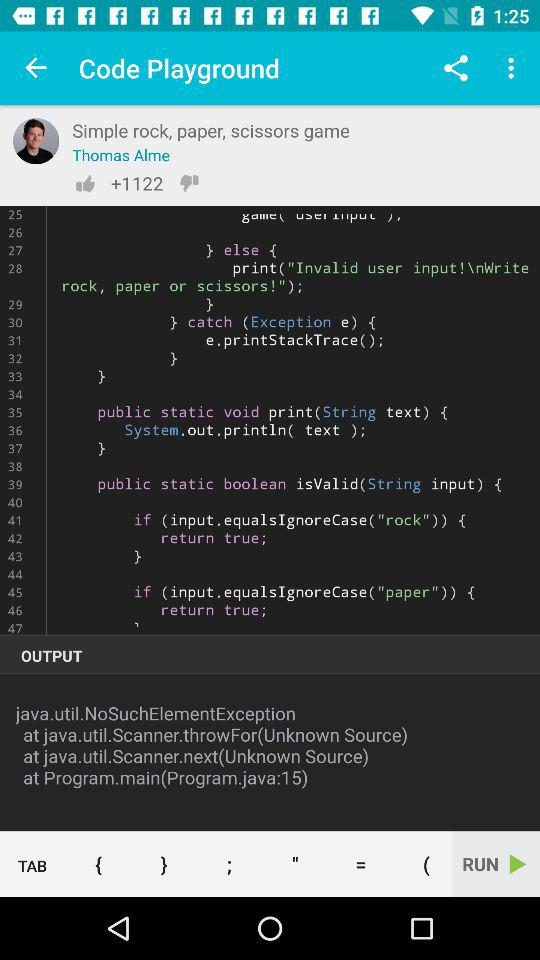How many likes are there? There are +1122 likes. 